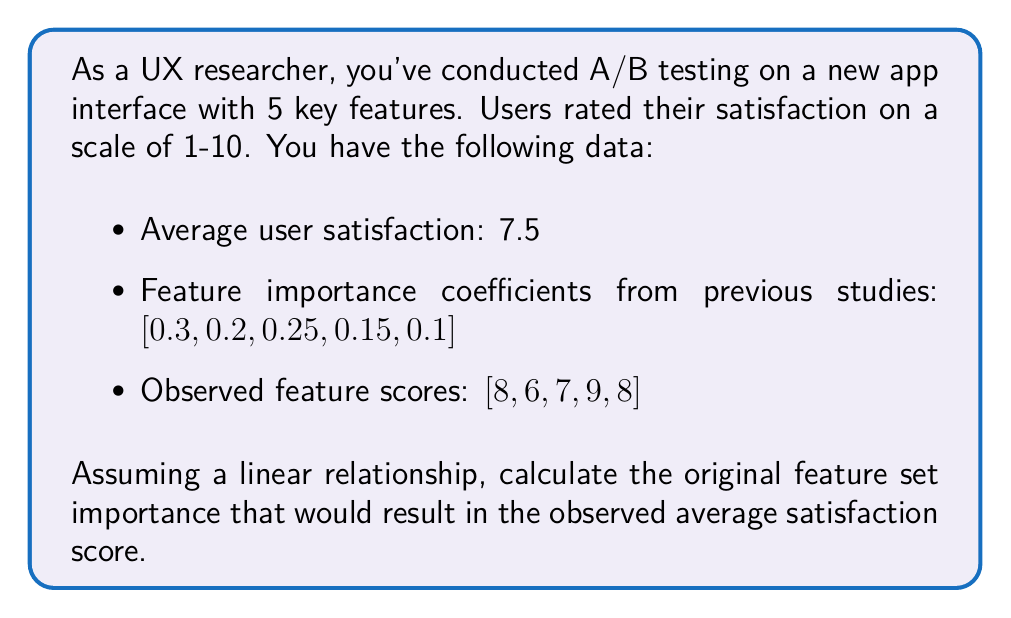Can you answer this question? Let's approach this step-by-step:

1) We assume a linear relationship between feature scores and overall satisfaction:

   $$ S = \sum_{i=1}^{5} w_i f_i $$

   Where $S$ is the satisfaction score, $w_i$ are the feature importance weights, and $f_i$ are the feature scores.

2) We know the average satisfaction ($S$) is 7.5, and we have the observed feature scores ($f_i$). We need to find the weights ($w_i$).

3) We can set up the equation:

   $$ 7.5 = w_1(8) + w_2(6) + w_3(7) + w_4(9) + w_5(8) $$

4) We also know that the weights should sum to 1:

   $$ w_1 + w_2 + w_3 + w_4 + w_5 = 1 $$

5) This is an underdetermined system. To solve it, we can use the given importance coefficients as a starting point and adjust them proportionally.

6) Let's call our adjustment factor $x$. Then:

   $$ 7.5 = 0.3x(8) + 0.2x(6) + 0.25x(7) + 0.15x(9) + 0.1x(8) $$

7) Simplifying:

   $$ 7.5 = x(2.4 + 1.2 + 1.75 + 1.35 + 0.8) = 7.5x $$

8) Solving for $x$:

   $$ x = \frac{7.5}{7.5} = 1 $$

9) Therefore, the original importance coefficients were correct and no adjustment is needed.
Answer: [0.3, 0.2, 0.25, 0.15, 0.1] 